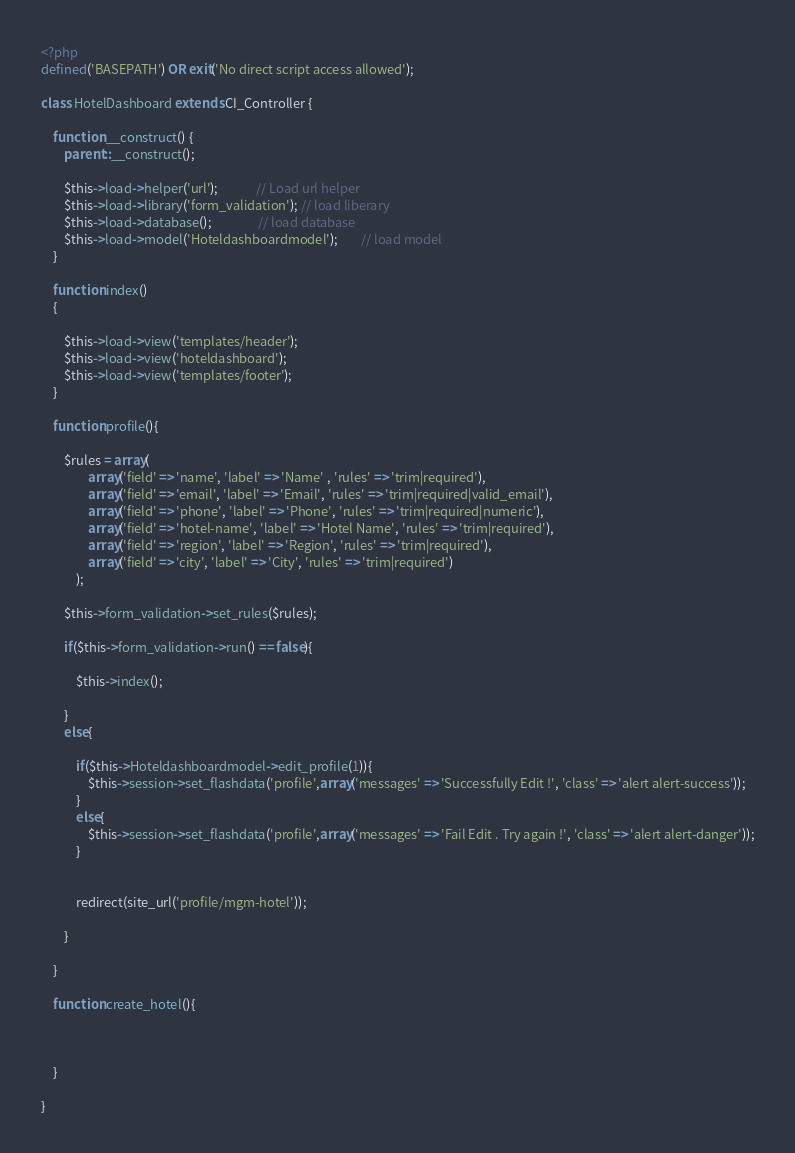<code> <loc_0><loc_0><loc_500><loc_500><_PHP_><?php
defined('BASEPATH') OR exit('No direct script access allowed');

class HotelDashboard extends CI_Controller {

	function __construct() {
        parent::__construct();
    
        $this->load->helper('url');             // Load url helper
        $this->load->library('form_validation'); // load liberary
        $this->load->database();                // load database
        $this->load->model('Hoteldashboardmodel');        // load model
    }

	function index()
	{
		
		$this->load->view('templates/header');
		$this->load->view('hoteldashboard');
		$this->load->view('templates/footer');																																
	}

	function profile(){

		$rules = array(
				array('field' => 'name', 'label' => 'Name' , 'rules' => 'trim|required'),
				array('field' => 'email', 'label' => 'Email', 'rules' => 'trim|required|valid_email'),
				array('field' => 'phone', 'label' => 'Phone', 'rules' => 'trim|required|numeric'),
				array('field' => 'hotel-name', 'label' => 'Hotel Name', 'rules' => 'trim|required'),
				array('field' => 'region', 'label' => 'Region', 'rules' => 'trim|required'),
				array('field' => 'city', 'label' => 'City', 'rules' => 'trim|required')
			);

		$this->form_validation->set_rules($rules);

		if($this->form_validation->run() == false){

			$this->index();

		}
		else{

			if($this->Hoteldashboardmodel->edit_profile(1)){
				$this->session->set_flashdata('profile',array('messages' => 'Successfully Edit !', 'class' => 'alert alert-success'));
			}
			else{
				$this->session->set_flashdata('profile',array('messages' => 'Fail Edit . Try again !', 'class' => 'alert alert-danger'));
			}

			
			redirect(site_url('profile/mgm-hotel'));

		}

	}

	function create_hotel(){

		
		
	}

}
</code> 